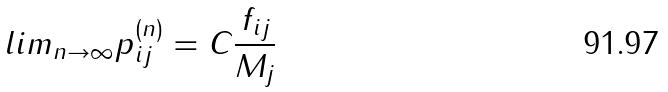Convert formula to latex. <formula><loc_0><loc_0><loc_500><loc_500>l i m _ { n \rightarrow \infty } p _ { i j } ^ { ( n ) } = C \frac { f _ { i j } } { M _ { j } }</formula> 